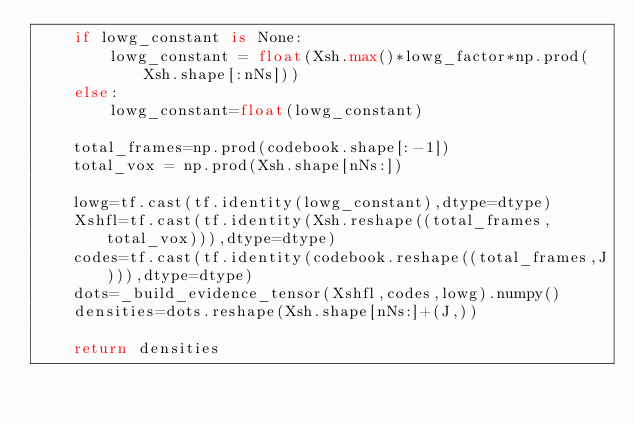<code> <loc_0><loc_0><loc_500><loc_500><_Python_>    if lowg_constant is None:
        lowg_constant = float(Xsh.max()*lowg_factor*np.prod(Xsh.shape[:nNs]))
    else:
        lowg_constant=float(lowg_constant)

    total_frames=np.prod(codebook.shape[:-1])
    total_vox = np.prod(Xsh.shape[nNs:])

    lowg=tf.cast(tf.identity(lowg_constant),dtype=dtype)
    Xshfl=tf.cast(tf.identity(Xsh.reshape((total_frames,total_vox))),dtype=dtype)
    codes=tf.cast(tf.identity(codebook.reshape((total_frames,J))),dtype=dtype)
    dots=_build_evidence_tensor(Xshfl,codes,lowg).numpy()
    densities=dots.reshape(Xsh.shape[nNs:]+(J,))

    return densities

</code> 